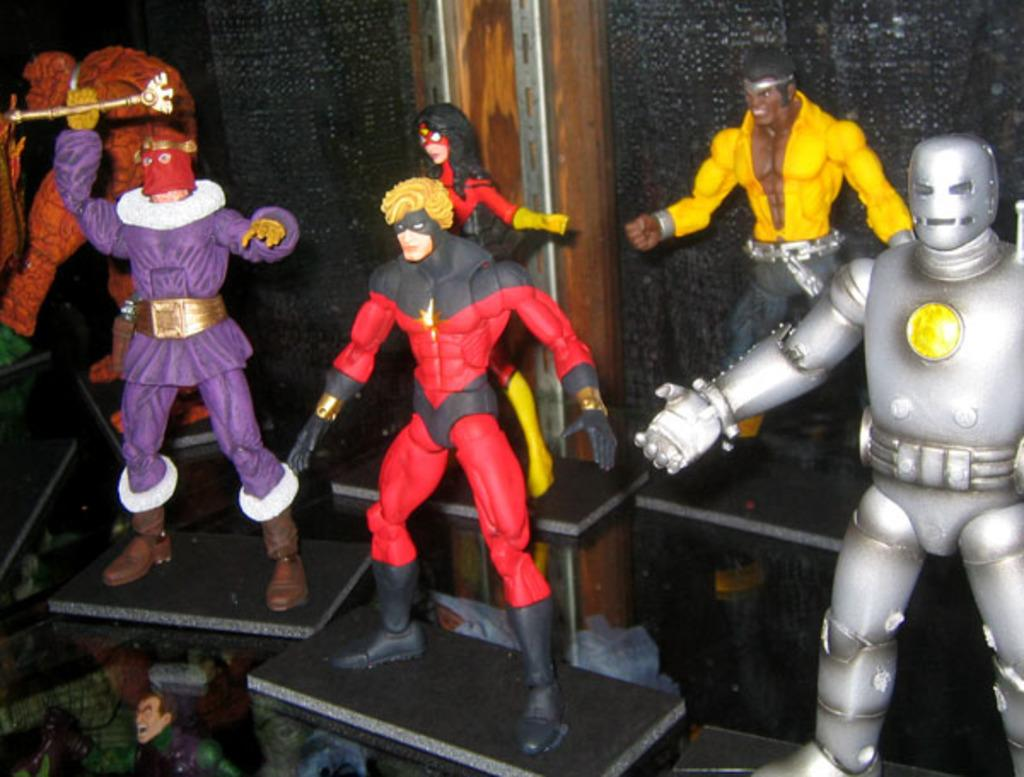What type of objects can be seen in the image? There are toys in the image. Can you see any ants carrying the toys in the image? There are no ants present in the image, and therefore they cannot be seen carrying the toys. 